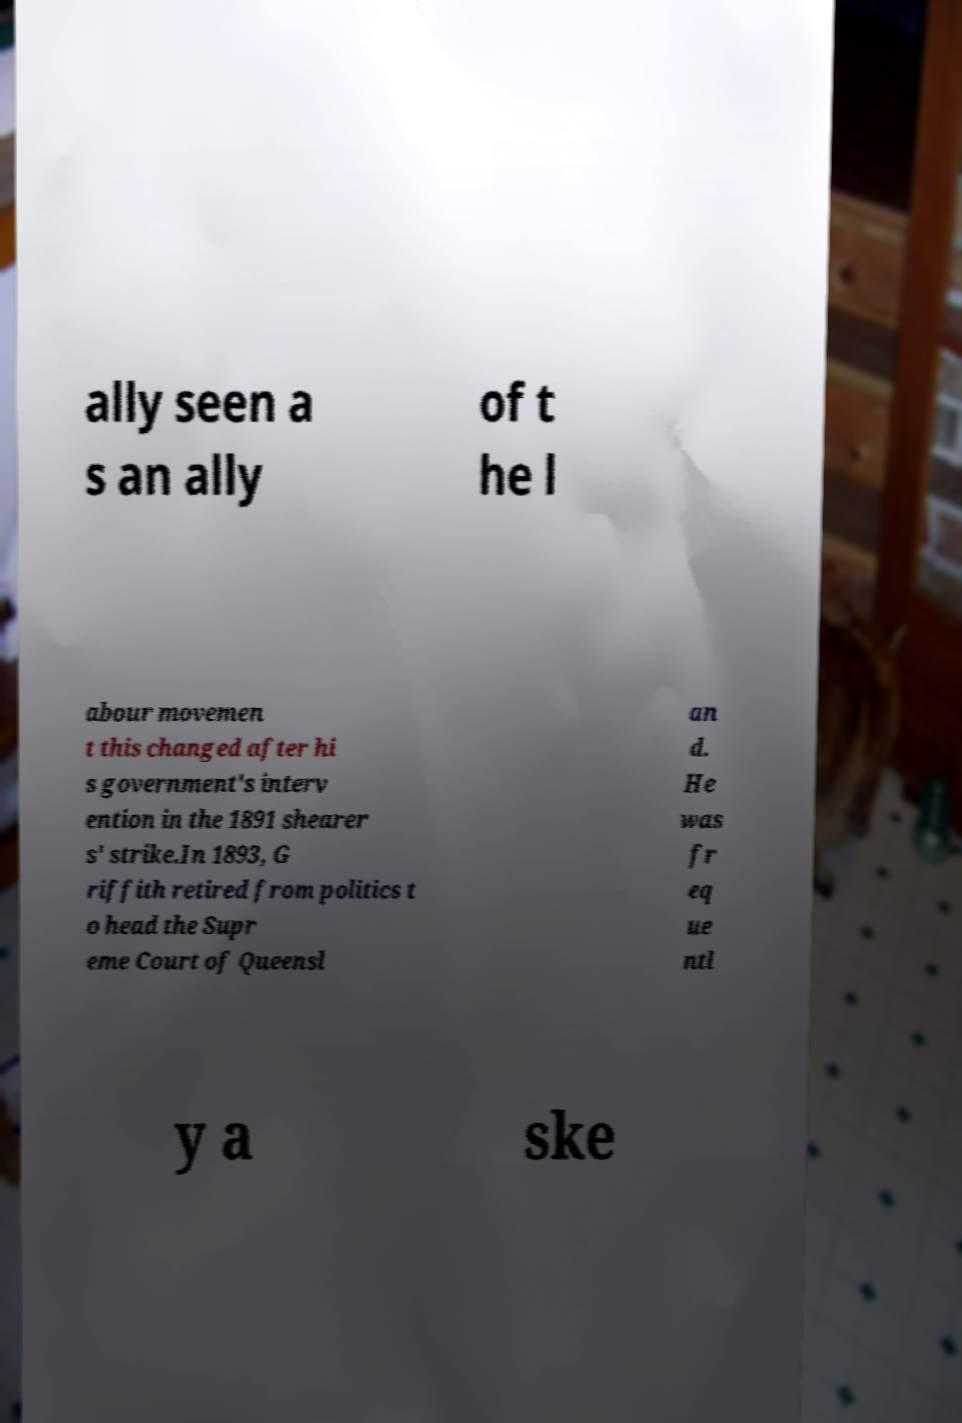I need the written content from this picture converted into text. Can you do that? ally seen a s an ally of t he l abour movemen t this changed after hi s government's interv ention in the 1891 shearer s' strike.In 1893, G riffith retired from politics t o head the Supr eme Court of Queensl an d. He was fr eq ue ntl y a ske 